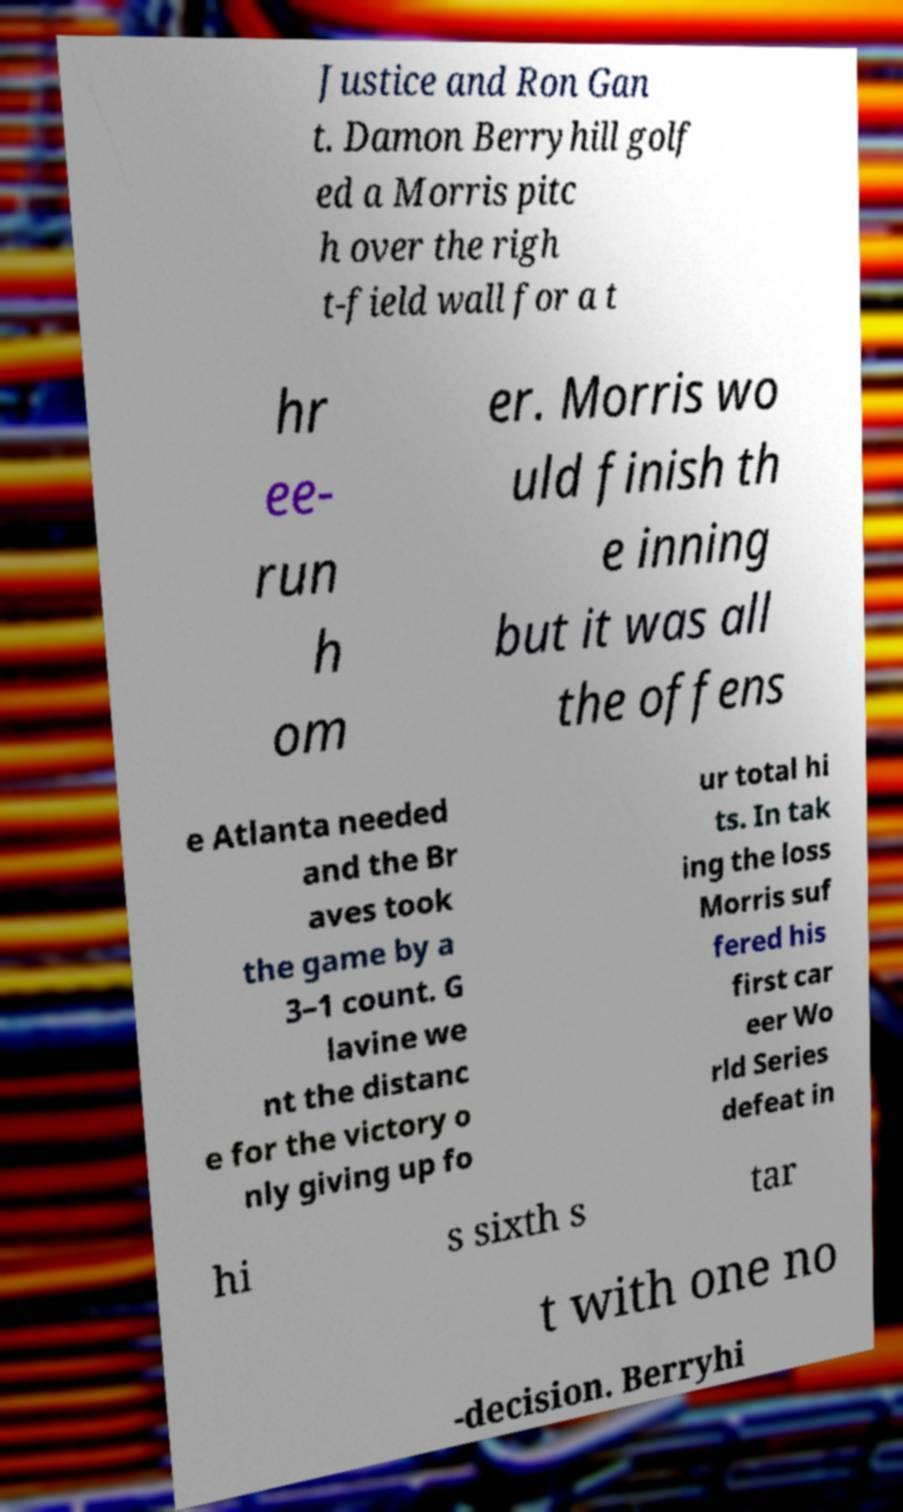Could you assist in decoding the text presented in this image and type it out clearly? Justice and Ron Gan t. Damon Berryhill golf ed a Morris pitc h over the righ t-field wall for a t hr ee- run h om er. Morris wo uld finish th e inning but it was all the offens e Atlanta needed and the Br aves took the game by a 3–1 count. G lavine we nt the distanc e for the victory o nly giving up fo ur total hi ts. In tak ing the loss Morris suf fered his first car eer Wo rld Series defeat in hi s sixth s tar t with one no -decision. Berryhi 